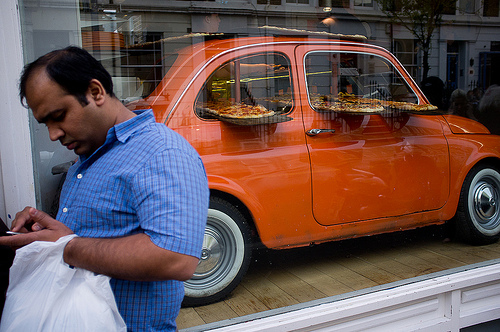<image>
Can you confirm if the car is in front of the window? No. The car is not in front of the window. The spatial positioning shows a different relationship between these objects. 